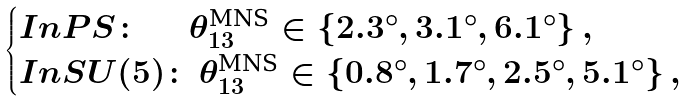Convert formula to latex. <formula><loc_0><loc_0><loc_500><loc_500>\begin{cases} I n P S \colon \, \quad \, \theta _ { 1 3 } ^ { \text {MNS} } \in \{ 2 . 3 ^ { \circ } , 3 . 1 ^ { \circ } , 6 . 1 ^ { \circ } \} \, , \\ I n S U ( 5 ) \colon \, \theta _ { 1 3 } ^ { \text {MNS} } \in \{ 0 . 8 ^ { \circ } , 1 . 7 ^ { \circ } , 2 . 5 ^ { \circ } , 5 . 1 ^ { \circ } \} \, , \end{cases}</formula> 